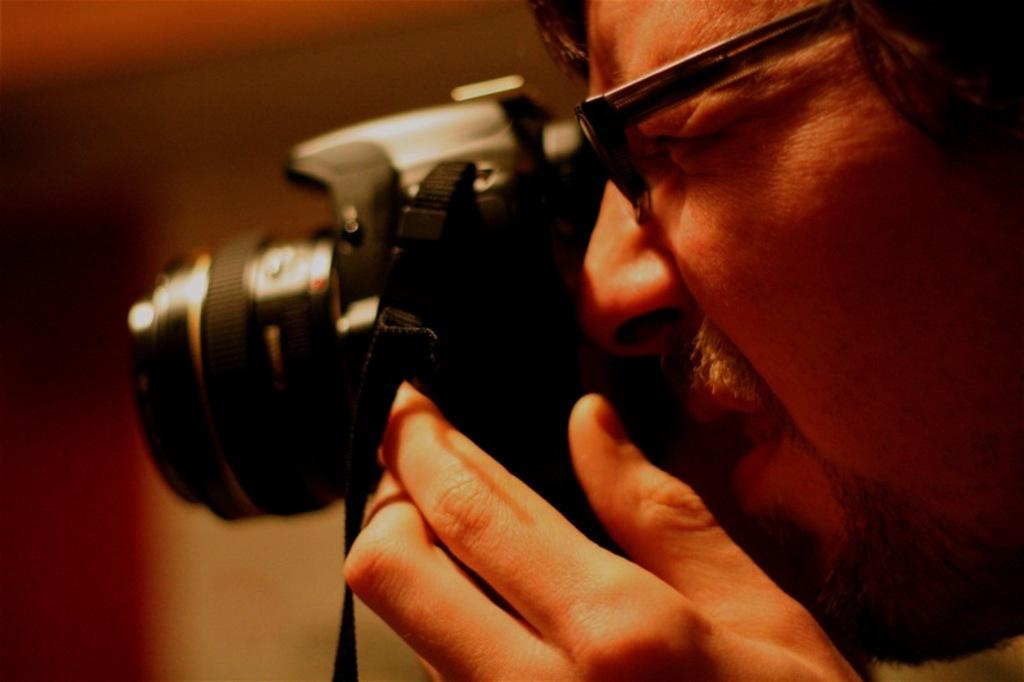Who is the main subject in the image? There is a man in the image. What is the man holding in his hand? The man is holding a camera in his hand. What is the man about to do with the camera? The man is ready to click a picture. What accessory is the man wearing in the image? The man is wearing spectacles. What type of wood can be seen in the image? There is no wood present in the image. Can you tell me how many quinces are in the man's hand? The man is holding a camera, not a quince, in his hand. 